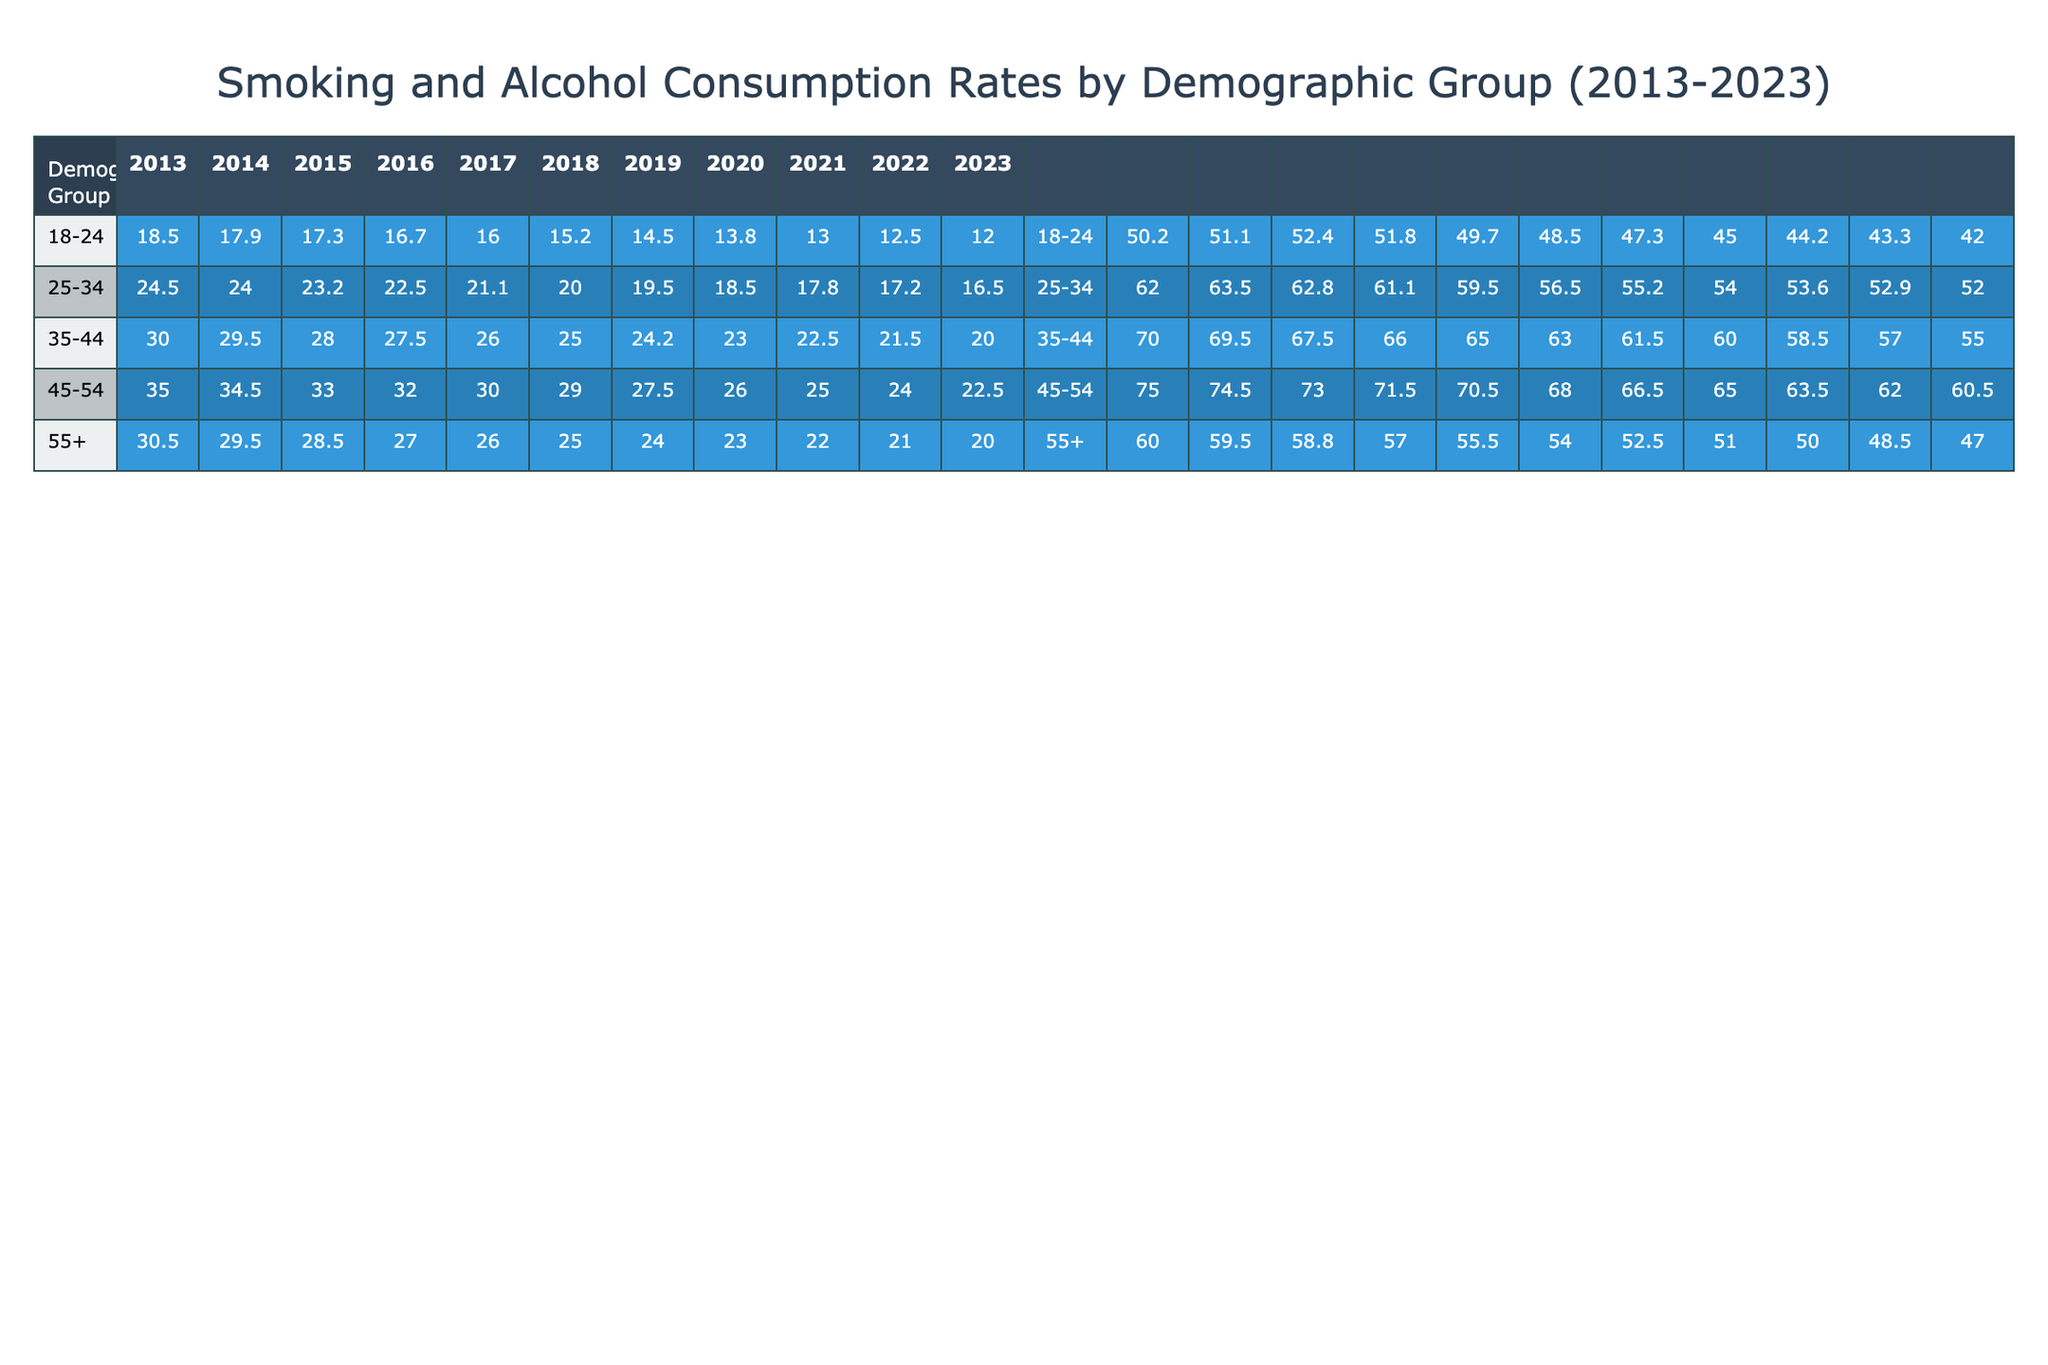What was the smoking rate among 25-34 year-olds in 2020? The table shows the smoking rate for the demographic group 25-34 for the year 2020 as 18.5%.
Answer: 18.5% What is the alcohol consumption rate for the 55+ demographic group in 2018? The table indicates that the alcohol consumption rate for the 55+ group in 2018 was 54.0%.
Answer: 54.0% Has the smoking rate for the 18-24 demographic group decreased from 2013 to 2023? A comparison of the values from the years shows that the smoking rate decreased from 18.5% in 2013 to 12.0% in 2023, confirming a decrease.
Answer: Yes What is the difference in smoking rates between the 35-44 and 45-54 age groups in 2022? In 2022, the smoking rate for 35-44 year-olds was 21.5%, while for 45-54 year-olds it was 24.0%. The difference is 24.0% - 21.5% = 2.5%.
Answer: 2.5% What was the average alcohol consumption rate for all age groups in 2023? The alcohol consumption rates in 2023 for each demographic group are 42.0% (18-24), 52.0% (25-34), 55.0% (35-44), 60.5% (45-54), and 47.0% (55+). The total is 42.0 + 52.0 + 55.0 + 60.5 + 47.0 = 256.5%. Dividing by 5 gives an average of 51.3%.
Answer: 51.3% Did the alcohol consumption rate for the 25-34 demographic group in 2015 exceed 60%? In 2015, the alcohol consumption rate for the 25-34 demographic group was 62.8%, which does exceed 60%.
Answer: Yes 